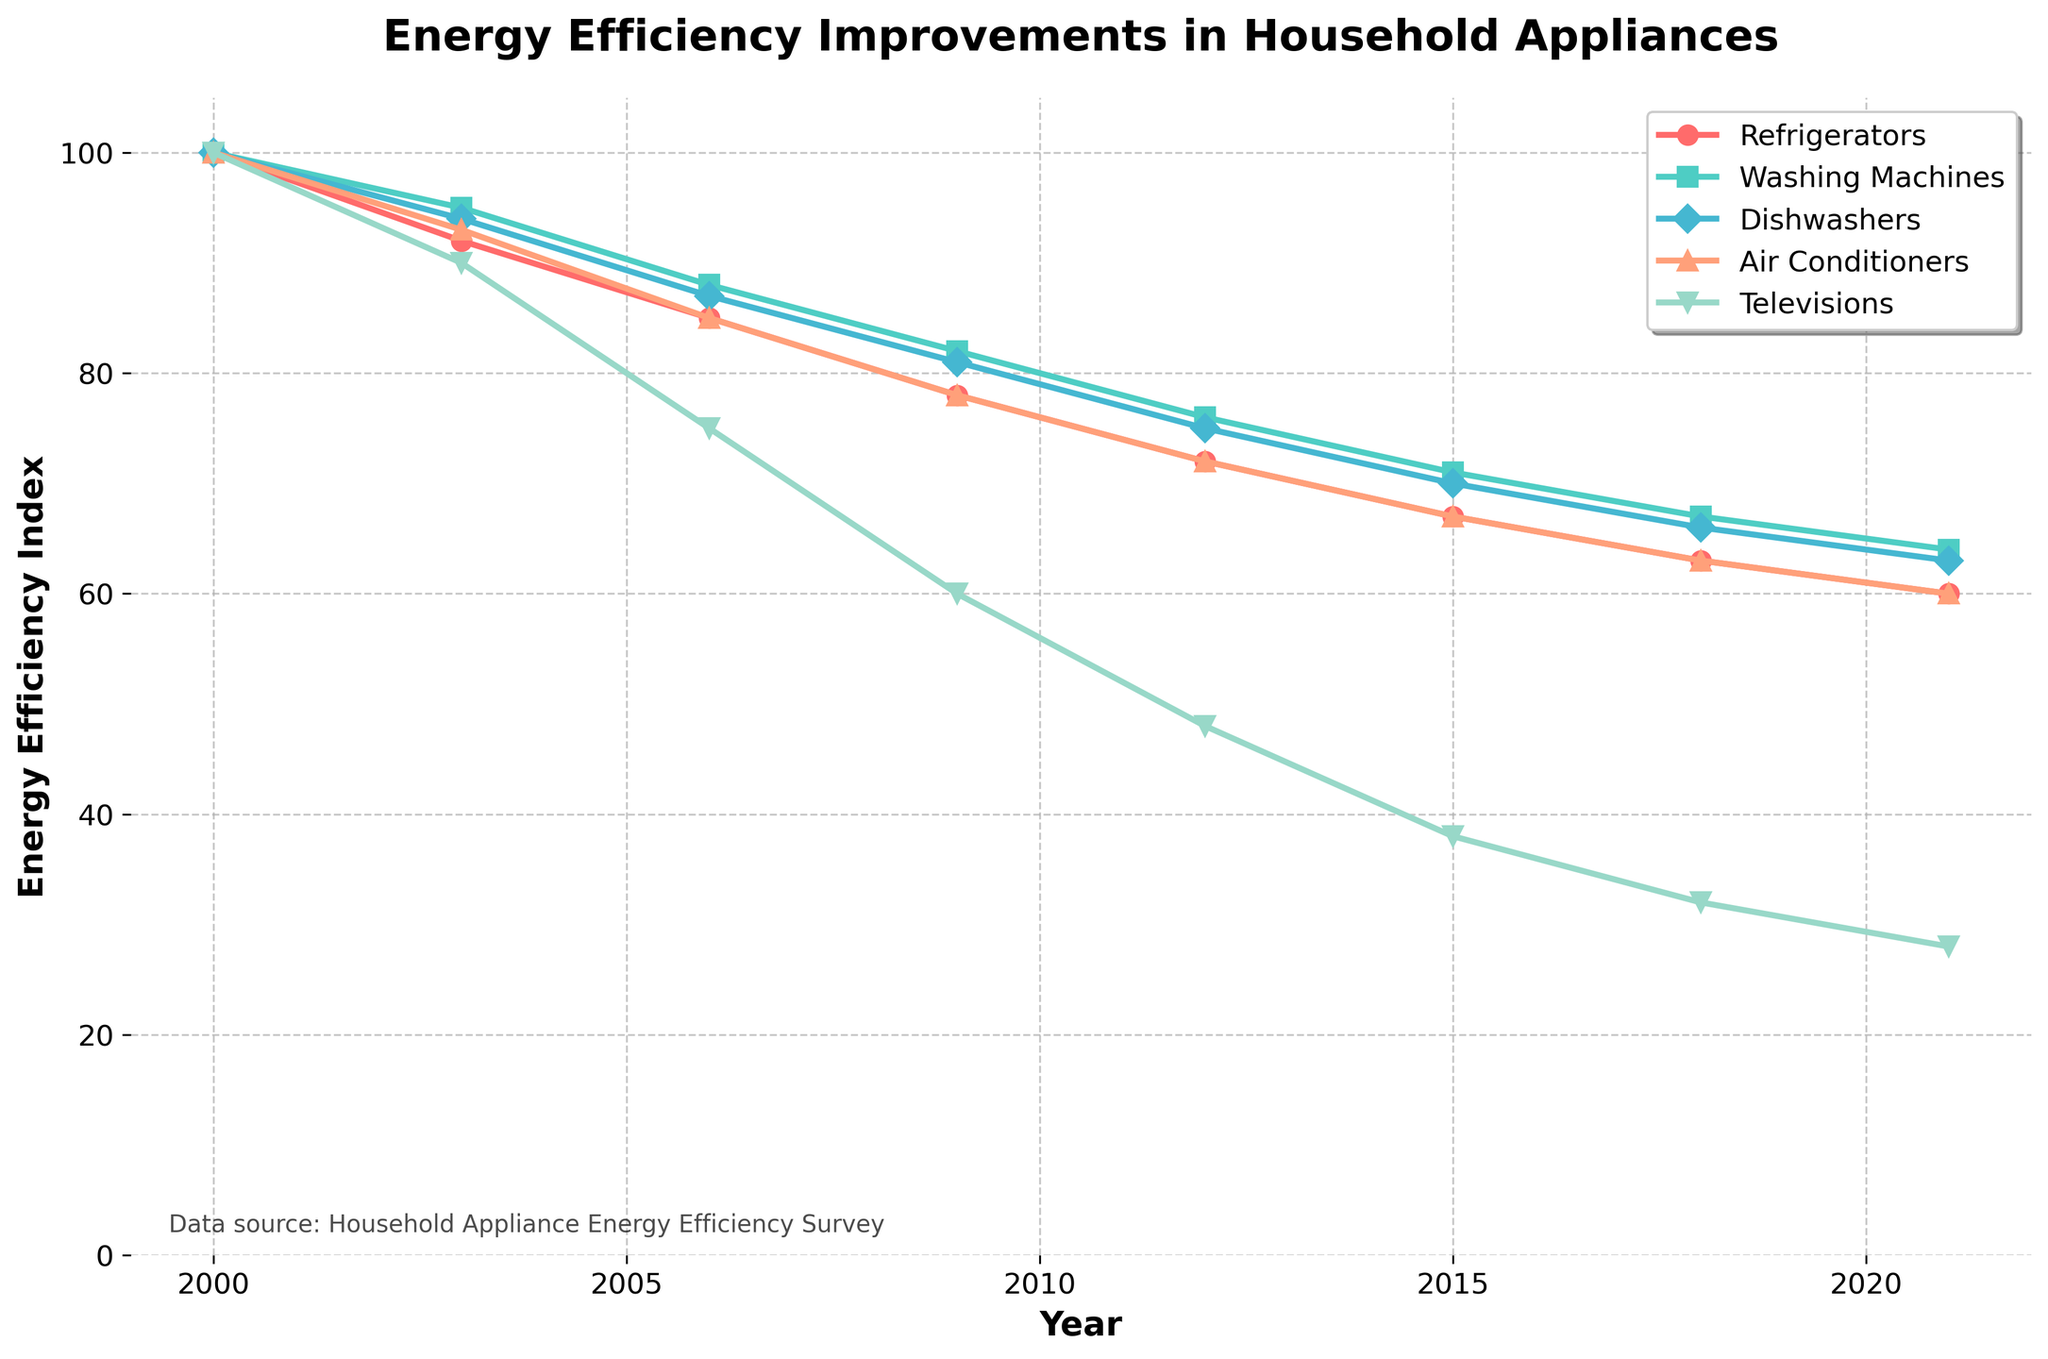What year did Refrigerators achieve their highest energy efficiency? By looking at the line for Refrigerators, it is lowest at the year 2021, indicating the highest energy efficiency.
Answer: 2021 Which appliance had the greatest improvement in energy efficiency from 2000 to 2021? Televisions show the most significant drop from 100 in 2000 to 28 in 2021, indicating the greatest improvement.
Answer: Televisions What was the energy efficiency index for Washing Machines in 2009? By looking at the line representing Washing Machines and noting the value at 2009, the index is at 82.
Answer: 82 Compare the energy efficiency indices of Dishwashers and Air Conditioners in 2015. Which one is more efficient? In 2015, Dishwashers have an index of 70 and Air Conditioners have an index of 67. Lower values indicate higher efficiency, so Air Conditioners are more efficient.
Answer: Air Conditioners Between 2006 and 2012, which appliance showed a steady improvement in energy efficiency without any year of stagnation or decline? By inspecting each line, Televisions show consistent improvement from 75 in 2006 to 48 in 2012.
Answer: Televisions Rank the appliances in terms of their energy efficiency index in 2018 from most efficient to least efficient. From the values in 2018, the indices are Refrigerators (63), Washing Machines (67), Dishwashers (66), Air Conditioners (63), and Televisions (32). The ranking from most efficient (lowest index) to least efficient is Televisions, Air Conditioners and Refrigerators (tie), Dishwashers, and Washing Machines.
Answer: Televisions, Air Conditioners and Refrigerators, Dishwashers, Washing Machines How did the energy efficiency of Refrigerators change between 2003 and 2009? The energy efficiency index for Refrigerators was 92 in 2003 and decreased to 78 in 2009, signifying an improvement.
Answer: Improved by 14 points What is the average energy efficiency index of Dishwashers over the years 2000, 2006, 2012, and 2021? The indices are 100 in 2000, 87 in 2006, 75 in 2012, and 63 in 2021. The average is (100 + 87 + 75 + 63) / 4 = 81.25.
Answer: 81.25 In which year did the Air Conditioners experience the greatest annual improvement in energy efficiency? Calculating the yearly differences, the biggest drop occurs between 2006 (85) and 2009 (78), a difference of 7 points.
Answer: 2009 Which appliance showed the smallest cumulative improvement in energy efficiency from 2000 to 2021? Comparing the overall decreases, Washing Machines decreased from 100 to 64, a reduction of 36 points, which is the smallest compared to others.
Answer: Washing Machines 